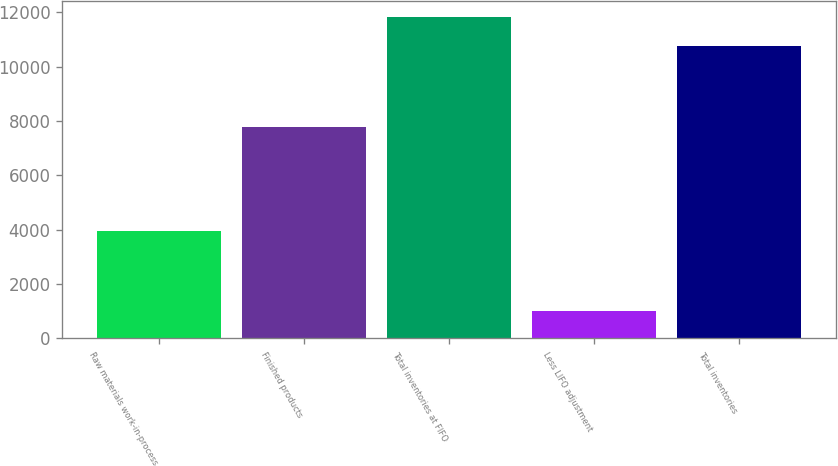Convert chart to OTSL. <chart><loc_0><loc_0><loc_500><loc_500><bar_chart><fcel>Raw materials work-in-process<fcel>Finished products<fcel>Total inventories at FIFO<fcel>Less LIFO adjustment<fcel>Total inventories<nl><fcel>3968<fcel>7799<fcel>11842.6<fcel>1001<fcel>10766<nl></chart> 